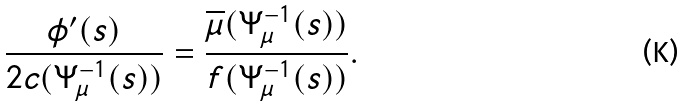Convert formula to latex. <formula><loc_0><loc_0><loc_500><loc_500>\frac { \phi ^ { \prime } ( s ) } { 2 c ( \Psi _ { \mu } ^ { - 1 } ( s ) ) } = \frac { \overline { \mu } ( \Psi _ { \mu } ^ { - 1 } ( s ) ) } { f ( \Psi _ { \mu } ^ { - 1 } ( s ) ) } .</formula> 